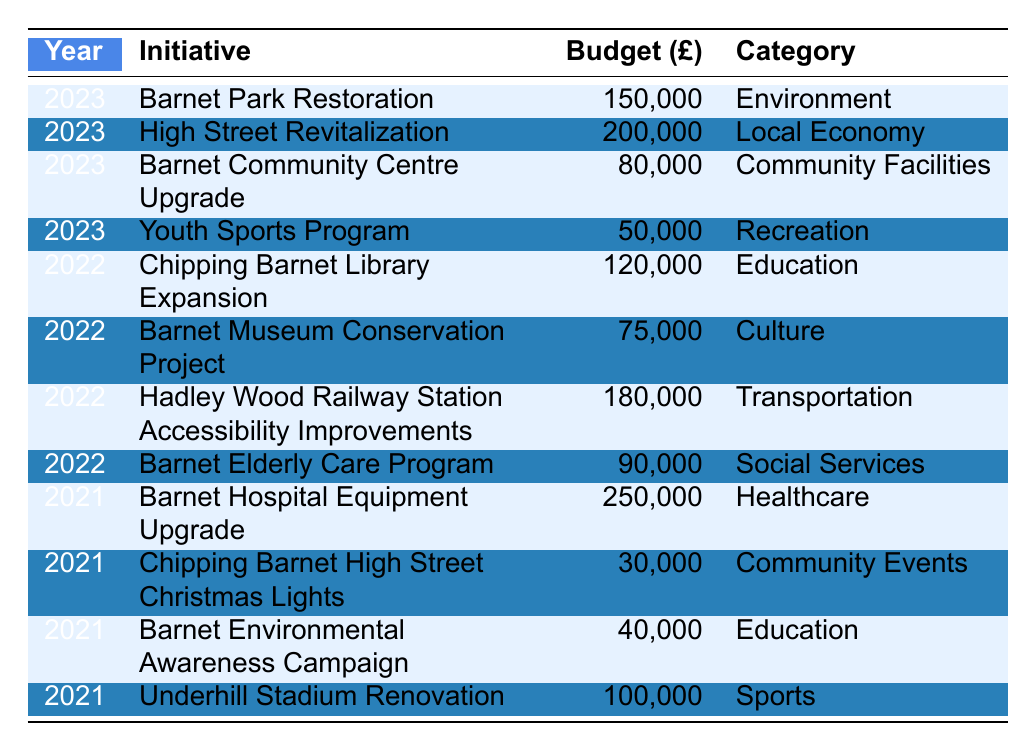What is the total budget allocated for initiatives in 2023? Adding the budgets for 2023 initiatives: 150,000 (Barnet Park Restoration) + 200,000 (High Street Revitalization) + 80,000 (Barnet Community Centre Upgrade) + 50,000 (Youth Sports Program) gives a total of 480,000.
Answer: 480000 Which initiative received the highest budget in 2021? Looking at the budgets for 2021: 250,000 (Barnet Hospital Equipment Upgrade), 30,000 (Chipping Barnet High Street Christmas Lights), 40,000 (Barnet Environmental Awareness Campaign), and 100,000 (Underhill Stadium Renovation), the highest is 250,000 for Barnet Hospital Equipment Upgrade.
Answer: Barnet Hospital Equipment Upgrade How much budget was allocated to education-related initiatives across all years? The education-related initiatives are: 120,000 (Chipping Barnet Library Expansion in 2022) + 40,000 (Barnet Environmental Awareness Campaign in 2021). Summing these gives 160,000.
Answer: 160000 Did any initiative in 2022 have a budget higher than 100,000? The budgets for 2022 initiatives include 120,000 (Chipping Barnet Library Expansion) and 180,000 (Hadley Wood Railway Station Accessibility Improvements), both of which are higher than 100,000.
Answer: Yes What is the average budget for all initiatives in 2022? The total budget for 2022 initiatives is 120,000 (Library Expansion) + 75,000 (Museum Conservation) + 180,000 (Accessibility Improvements) + 90,000 (Elderly Care Program) = 465,000. There are 4 initiatives, so the average is 465,000 / 4 = 116,250.
Answer: 116250 How many initiatives in the table focus on the environment? The initiatives related to environment are: Barnet Park Restoration in 2023 and Barnet Environmental Awareness Campaign in 2021, making it a total of 2 initiatives.
Answer: 2 Which category has the most allocated budget in 2021? The categories for 2021 are: Healthcare (250,000), Community Events (30,000), Education (40,000), and Sports (100,000). The highest is Healthcare with 250,000.
Answer: Healthcare What is the difference in budget allocations between the highest and lowest initiatives in 2023? The highest budget in 2023 is 200,000 (High Street Revitalization) and the lowest is 50,000 (Youth Sports Program). The difference is 200,000 - 50,000 = 150,000.
Answer: 150000 Is there any initiative listed for funding in 2021 that was also funded in 2022? No initiative is listed in both 2021 and 2022, as all initiatives in 2021 are unique to that year.
Answer: No What is the total budget for local economy initiatives across all years? There is one local economy initiative: 200,000 (High Street Revitalization in 2023). The total budget is just 200,000.
Answer: 200000 